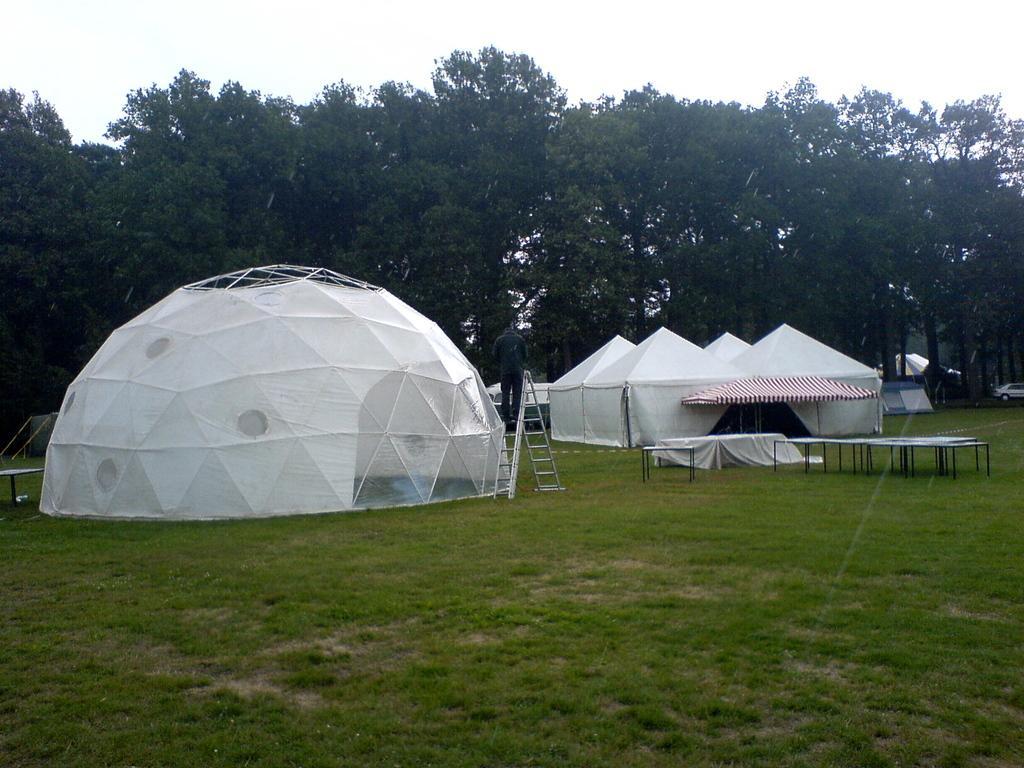Can you describe this image briefly? In this image we can see many trees and tents. There is a sky in the image. There is a grassy land in the image. There are few vehicles in the image. 